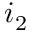Convert formula to latex. <formula><loc_0><loc_0><loc_500><loc_500>i _ { 2 }</formula> 